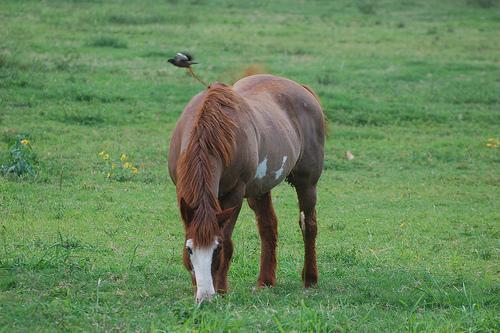How many animals?
Give a very brief answer. 2. 